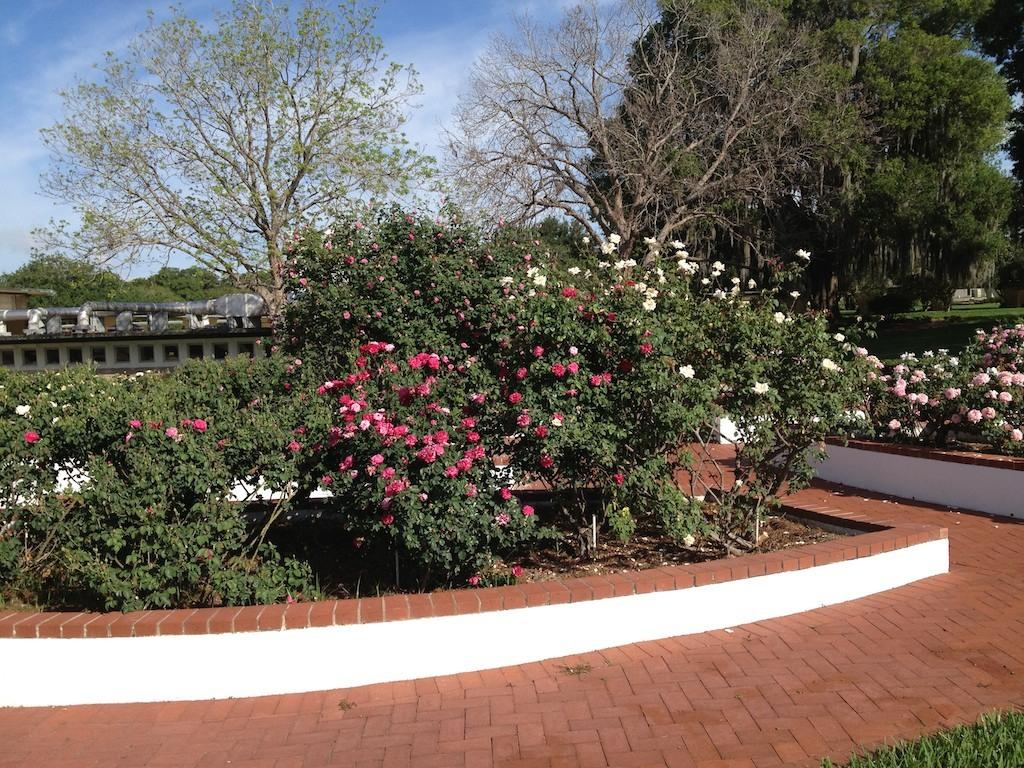What type of vegetation can be seen in the image? There are plants, trees, and flowers in the image. What can be used for walking or traveling in the image? There is a path in the image for walking or traveling. What is on top of the building in the image? There are pipes on top of a building in the image. What is visible in the background of the image? The sky is visible in the background of the image. What type of needle is used to play the music in the image? There is no needle or music present in the image. How many dimes can be seen on the path in the image? There are no dimes present in the image. 